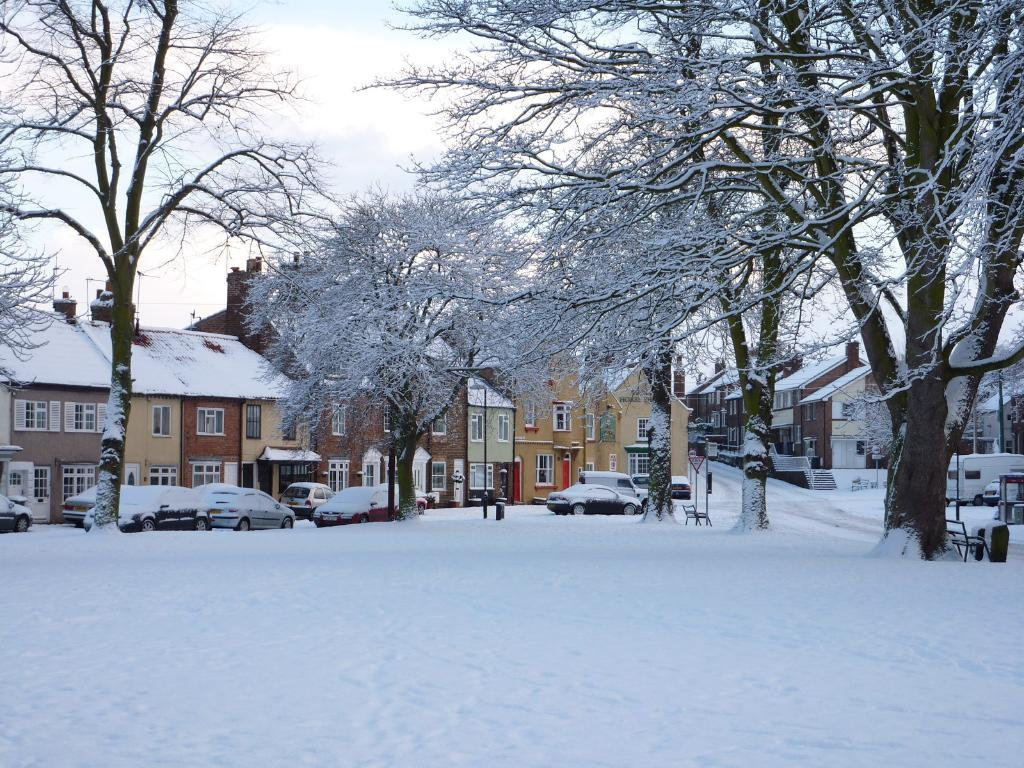What type of weather is depicted in the image? There is snow in the image, indicating a winter scene. What type of vehicles can be seen in the image? There are cars in the image. What type of structures are present in the image? There are poles, trees, a bench, buildings, and stairs in the image. What is visible in the sky in the image? The sky is visible in the image. What is the purpose of the coach in the image? There is no coach present in the image. What type of amusement can be seen in the image? There is no amusement depicted in the image; it shows a snowy scene with cars, poles, trees, a bench, buildings, stairs, and the sky. 